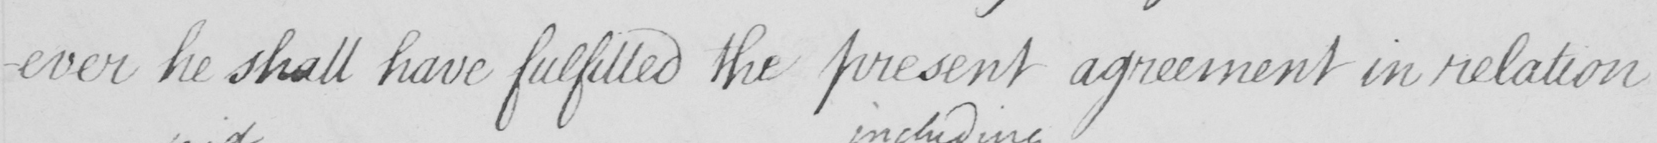What text is written in this handwritten line? -ever he shall have fulfilled the present agreement in relation 